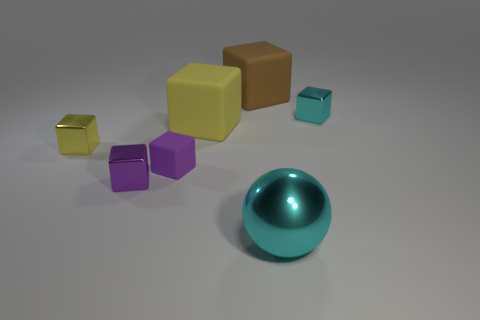The large thing that is both behind the yellow shiny cube and in front of the brown object has what shape?
Your answer should be compact. Cube. The matte thing that is the same size as the purple metallic object is what color?
Provide a short and direct response. Purple. Does the cyan metal thing in front of the tiny cyan shiny cube have the same size as the yellow block that is to the right of the purple shiny object?
Offer a very short reply. Yes. How big is the thing that is behind the metal thing that is behind the thing that is on the left side of the purple metallic block?
Offer a very short reply. Large. There is a cyan object in front of the tiny metal block that is right of the large shiny sphere; what is its shape?
Your response must be concise. Sphere. Do the tiny metal block to the right of the large brown matte thing and the small matte thing have the same color?
Provide a short and direct response. No. There is a large object that is both behind the large cyan ball and on the right side of the yellow matte object; what color is it?
Give a very brief answer. Brown. Are there any big red cubes that have the same material as the big brown cube?
Offer a very short reply. No. What is the size of the yellow metal thing?
Keep it short and to the point. Small. What is the size of the yellow rubber object that is behind the tiny purple rubber cube to the left of the large brown matte block?
Provide a short and direct response. Large. 